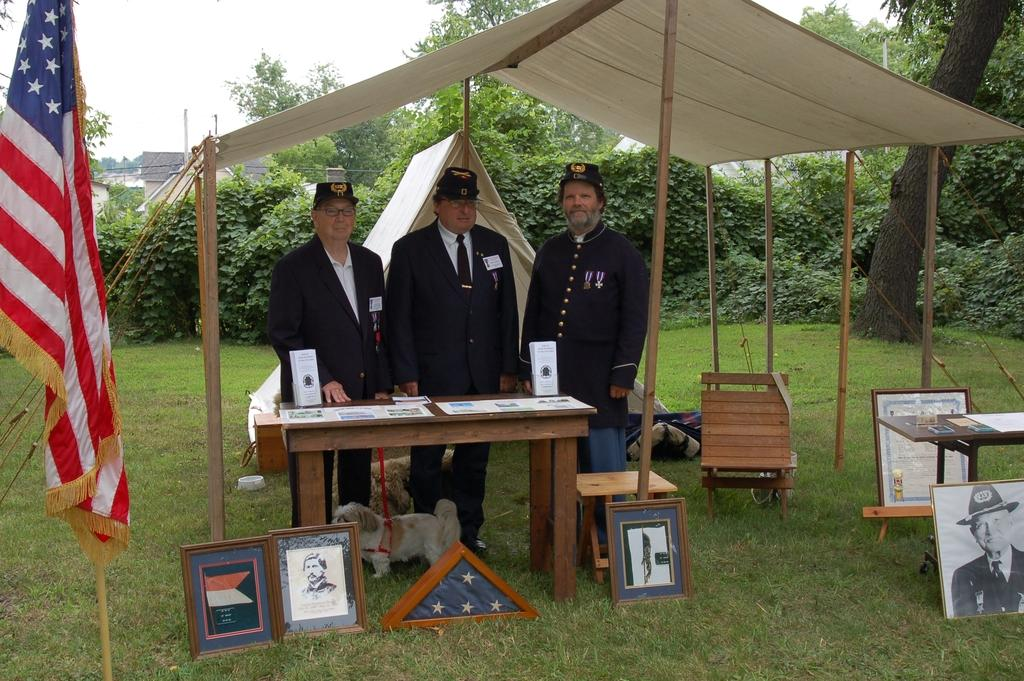What are the people in the image doing? The people in the image are standing near a table. What animals can be seen in the image? There are dogs in the image. What type of furniture is present in the image? There is a table and chairs visible in the image. What objects are used for displaying photos? Photo frames are present in the image. What temporary shelter is visible in the image? There is a tent in the image. What decorative items can be seen in the image? Flags are present in the image. What natural elements are visible in the background of the image? Trees are visible in the background of the image. What type of quince is being used as a tablecloth in the image? There is no quince present in the image, let alone being used as a tablecloth. How many quilts are visible on the chairs in the image? There are no quilts visible in the image; only chairs are present. 